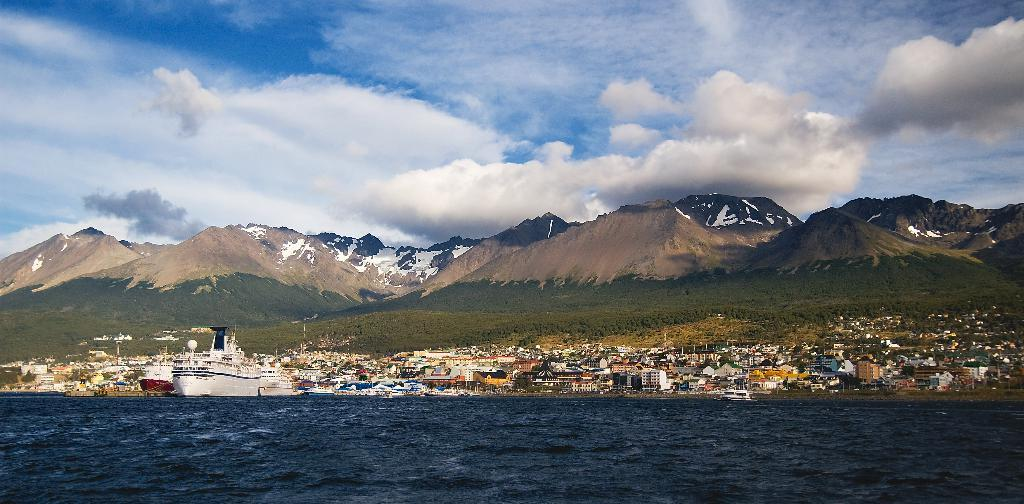What is on the water in the image? There are ships on the water in the image. What type of structures can be seen in the image? There are buildings visible in the image. What natural features are present in the image? Hills and mountains are visible in the image. What part of the natural environment is visible in the image? The sky is visible in the image. What can be seen in the sky? Clouds are present in the sky. What type of cannon is used to create the design of the ships in the image? There is no mention of a cannon or any design process in the image. The image simply shows ships on the water, buildings, hills, mountains, and the sky with clouds. 